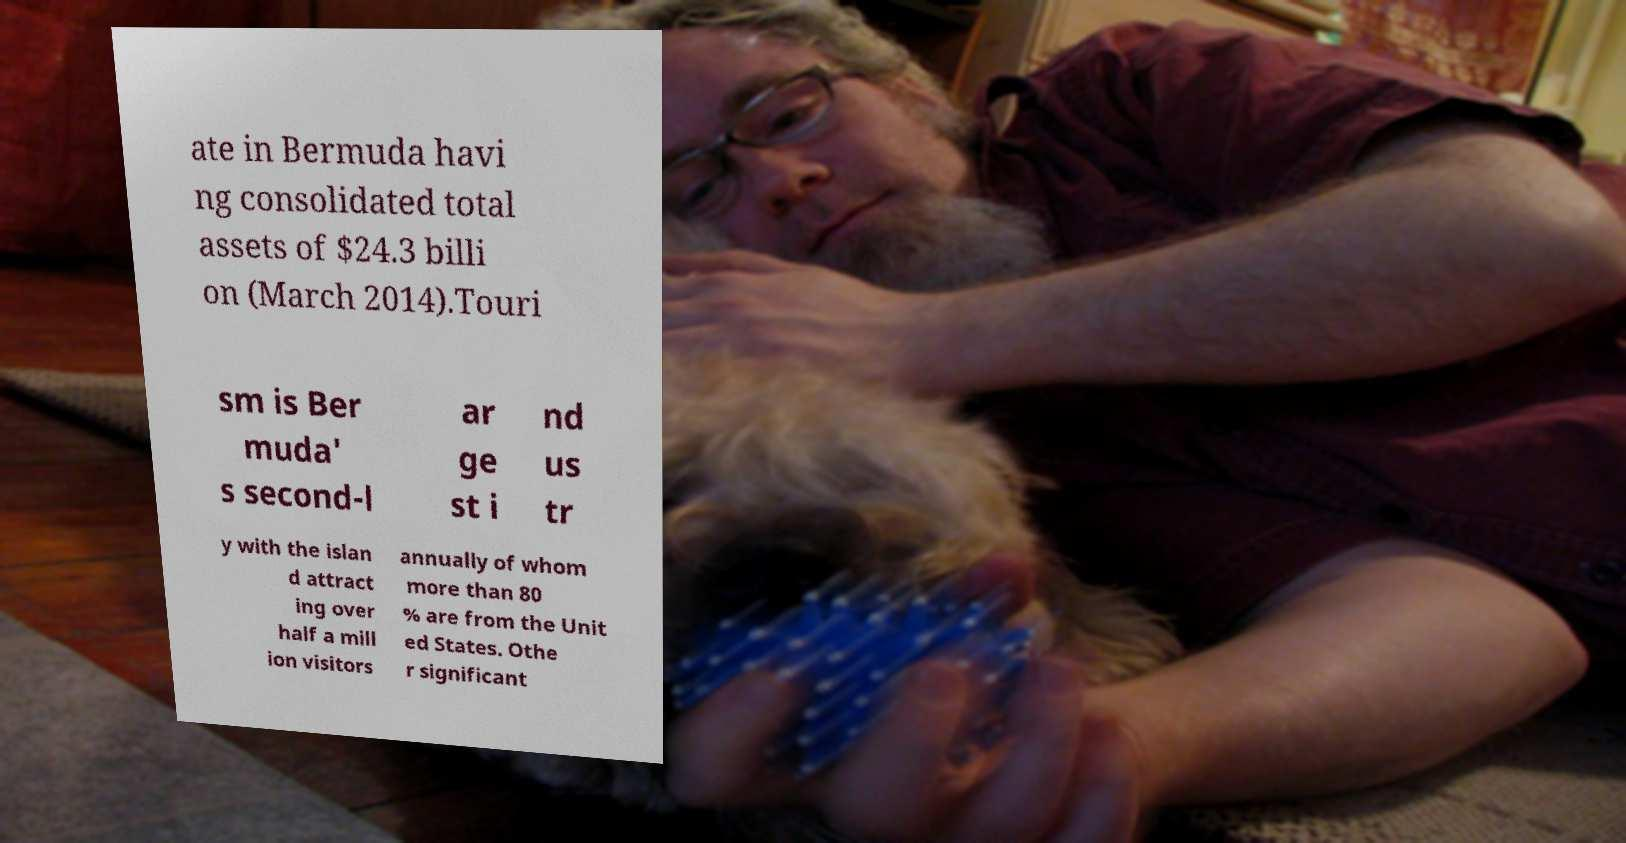Please identify and transcribe the text found in this image. ate in Bermuda havi ng consolidated total assets of $24.3 billi on (March 2014).Touri sm is Ber muda' s second-l ar ge st i nd us tr y with the islan d attract ing over half a mill ion visitors annually of whom more than 80 % are from the Unit ed States. Othe r significant 